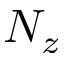<formula> <loc_0><loc_0><loc_500><loc_500>N _ { z }</formula> 